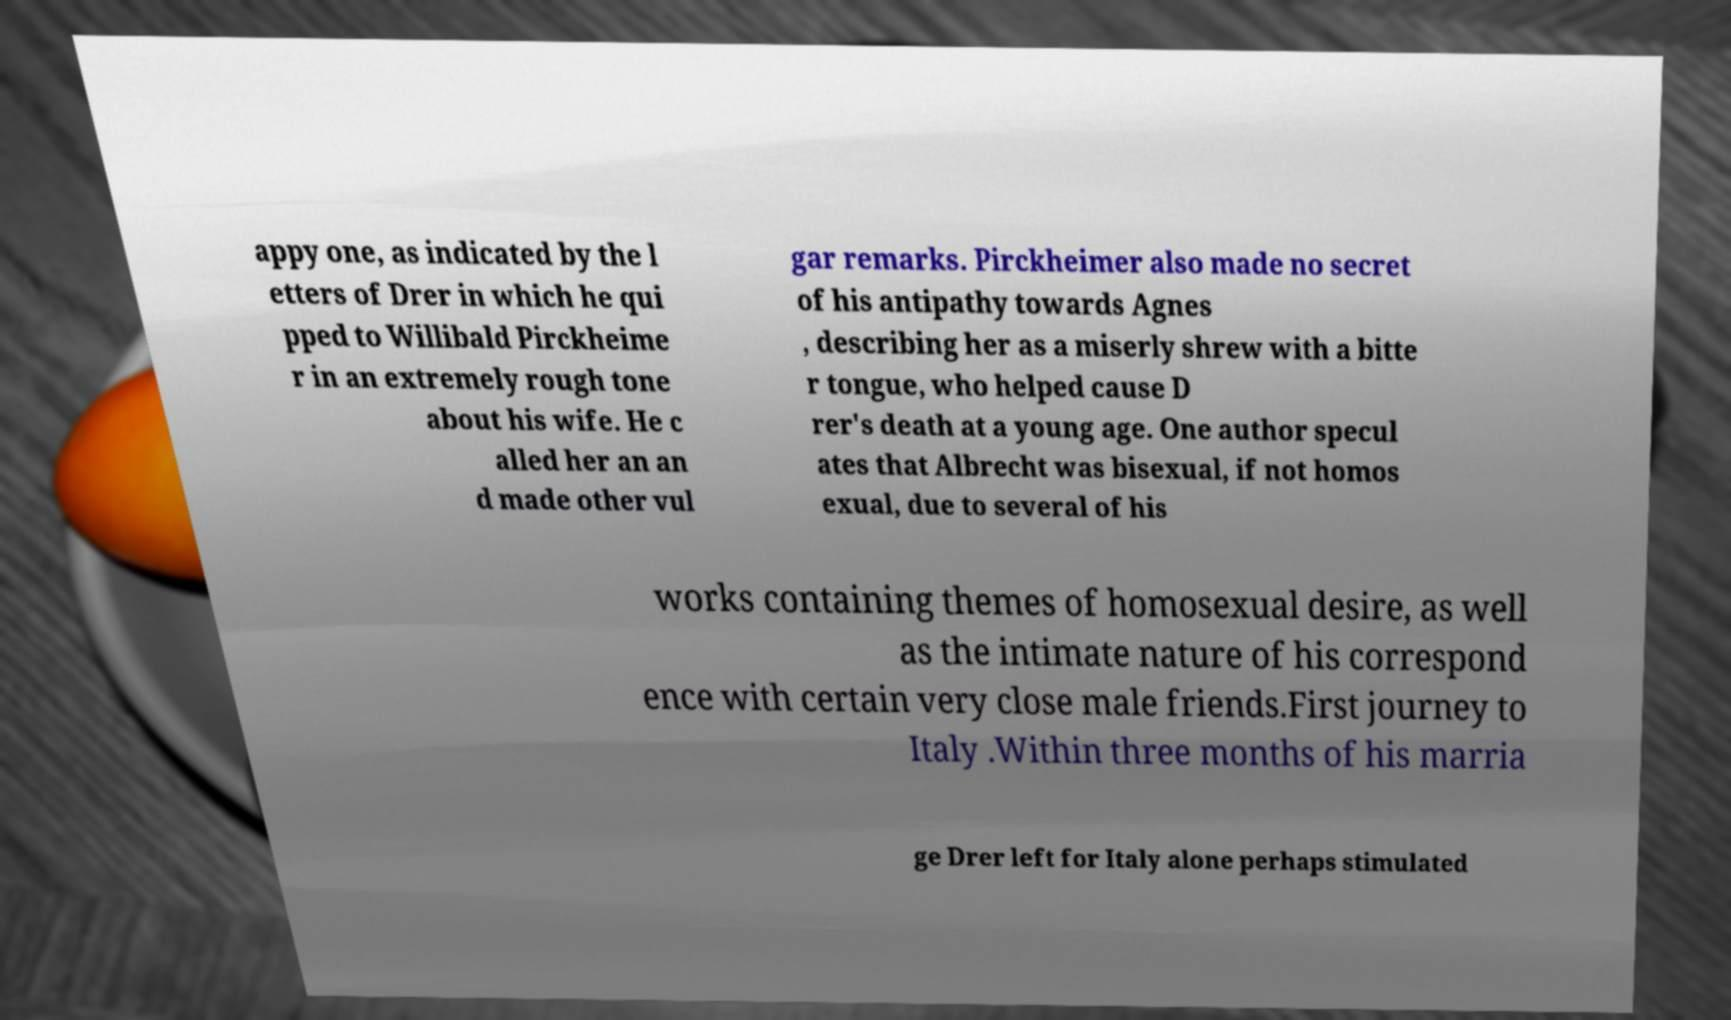Please read and relay the text visible in this image. What does it say? appy one, as indicated by the l etters of Drer in which he qui pped to Willibald Pirckheime r in an extremely rough tone about his wife. He c alled her an an d made other vul gar remarks. Pirckheimer also made no secret of his antipathy towards Agnes , describing her as a miserly shrew with a bitte r tongue, who helped cause D rer's death at a young age. One author specul ates that Albrecht was bisexual, if not homos exual, due to several of his works containing themes of homosexual desire, as well as the intimate nature of his correspond ence with certain very close male friends.First journey to Italy .Within three months of his marria ge Drer left for Italy alone perhaps stimulated 